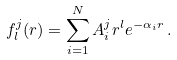<formula> <loc_0><loc_0><loc_500><loc_500>f _ { l } ^ { j } ( r ) = \sum _ { i = 1 } ^ { N } A _ { i } ^ { j } r ^ { l } e ^ { - \alpha _ { i } r } \, .</formula> 